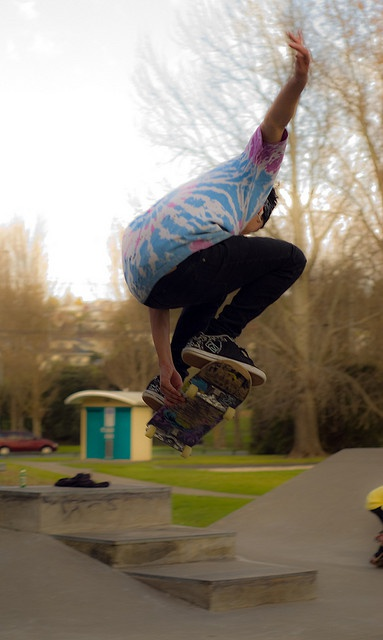Describe the objects in this image and their specific colors. I can see people in white, black, darkgray, and maroon tones, skateboard in white, black, olive, and gray tones, car in white, maroon, black, and gray tones, and bench in black, darkgreen, and white tones in this image. 